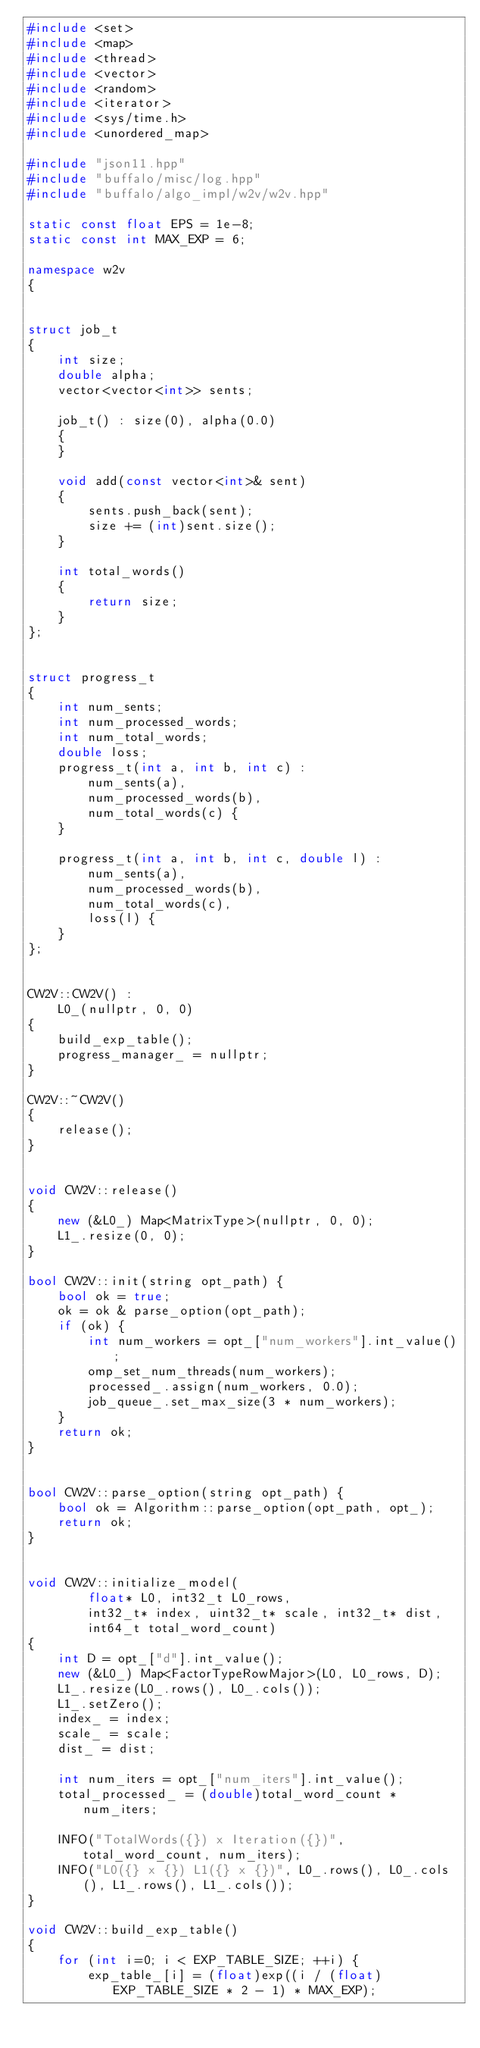Convert code to text. <code><loc_0><loc_0><loc_500><loc_500><_C++_>#include <set>
#include <map>
#include <thread>
#include <vector>
#include <random>
#include <iterator>
#include <sys/time.h>
#include <unordered_map>

#include "json11.hpp"
#include "buffalo/misc/log.hpp"
#include "buffalo/algo_impl/w2v/w2v.hpp"

static const float EPS = 1e-8;
static const int MAX_EXP = 6;

namespace w2v
{


struct job_t
{
    int size;
    double alpha;
    vector<vector<int>> sents;

    job_t() : size(0), alpha(0.0)
    {
    }

    void add(const vector<int>& sent)
    {
        sents.push_back(sent);
        size += (int)sent.size();
    }

    int total_words()
    {
        return size;
    }
};


struct progress_t
{
    int num_sents;
    int num_processed_words;
    int num_total_words;
    double loss;
    progress_t(int a, int b, int c) :
        num_sents(a),
        num_processed_words(b),
        num_total_words(c) {
    }

    progress_t(int a, int b, int c, double l) :
        num_sents(a),
        num_processed_words(b),
        num_total_words(c),
        loss(l) {
    }
};


CW2V::CW2V() :
    L0_(nullptr, 0, 0)
{
    build_exp_table();
    progress_manager_ = nullptr;
}

CW2V::~CW2V()
{
    release();
}


void CW2V::release()
{
    new (&L0_) Map<MatrixType>(nullptr, 0, 0);
    L1_.resize(0, 0);
}

bool CW2V::init(string opt_path) {
    bool ok = true;
    ok = ok & parse_option(opt_path);
    if (ok) {
        int num_workers = opt_["num_workers"].int_value();
        omp_set_num_threads(num_workers);
        processed_.assign(num_workers, 0.0);
        job_queue_.set_max_size(3 * num_workers);
    }
    return ok;
}


bool CW2V::parse_option(string opt_path) {
    bool ok = Algorithm::parse_option(opt_path, opt_);
    return ok;
}


void CW2V::initialize_model(
        float* L0, int32_t L0_rows,
        int32_t* index, uint32_t* scale, int32_t* dist,
        int64_t total_word_count)
{
    int D = opt_["d"].int_value();
    new (&L0_) Map<FactorTypeRowMajor>(L0, L0_rows, D);
    L1_.resize(L0_.rows(), L0_.cols());
    L1_.setZero();
    index_ = index;
    scale_ = scale;
    dist_ = dist;

    int num_iters = opt_["num_iters"].int_value();
    total_processed_ = (double)total_word_count * num_iters;

    INFO("TotalWords({}) x Iteration({})", total_word_count, num_iters);
    INFO("L0({} x {}) L1({} x {})", L0_.rows(), L0_.cols(), L1_.rows(), L1_.cols());
}

void CW2V::build_exp_table()
{
    for (int i=0; i < EXP_TABLE_SIZE; ++i) {
        exp_table_[i] = (float)exp((i / (float)EXP_TABLE_SIZE * 2 - 1) * MAX_EXP);</code> 